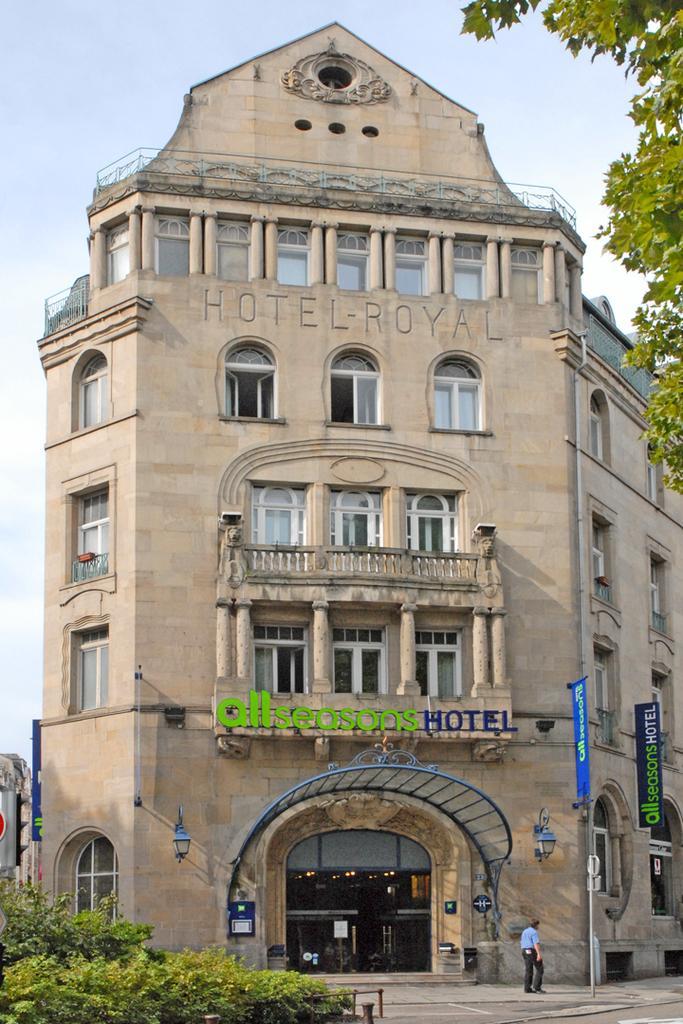Could you give a brief overview of what you see in this image? On the left side, there are plants. On the top right, there are branches of a tree having leaves. In the background, there is a person on a footpath, there is a building which is having windows and there are clouds in the sky. 